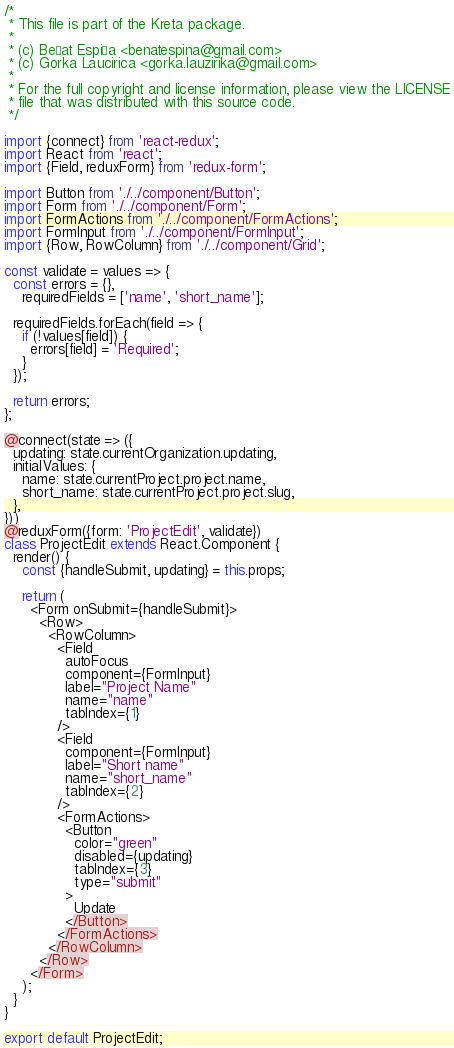Convert code to text. <code><loc_0><loc_0><loc_500><loc_500><_JavaScript_>/*
 * This file is part of the Kreta package.
 *
 * (c) Beñat Espiña <benatespina@gmail.com>
 * (c) Gorka Laucirica <gorka.lauzirika@gmail.com>
 *
 * For the full copyright and license information, please view the LICENSE
 * file that was distributed with this source code.
 */

import {connect} from 'react-redux';
import React from 'react';
import {Field, reduxForm} from 'redux-form';

import Button from './../component/Button';
import Form from './../component/Form';
import FormActions from './../component/FormActions';
import FormInput from './../component/FormInput';
import {Row, RowColumn} from './../component/Grid';

const validate = values => {
  const errors = {},
    requiredFields = ['name', 'short_name'];

  requiredFields.forEach(field => {
    if (!values[field]) {
      errors[field] = 'Required';
    }
  });

  return errors;
};

@connect(state => ({
  updating: state.currentOrganization.updating,
  initialValues: {
    name: state.currentProject.project.name,
    short_name: state.currentProject.project.slug,
  },
}))
@reduxForm({form: 'ProjectEdit', validate})
class ProjectEdit extends React.Component {
  render() {
    const {handleSubmit, updating} = this.props;

    return (
      <Form onSubmit={handleSubmit}>
        <Row>
          <RowColumn>
            <Field
              autoFocus
              component={FormInput}
              label="Project Name"
              name="name"
              tabIndex={1}
            />
            <Field
              component={FormInput}
              label="Short name"
              name="short_name"
              tabIndex={2}
            />
            <FormActions>
              <Button
                color="green"
                disabled={updating}
                tabIndex={3}
                type="submit"
              >
                Update
              </Button>
            </FormActions>
          </RowColumn>
        </Row>
      </Form>
    );
  }
}

export default ProjectEdit;
</code> 